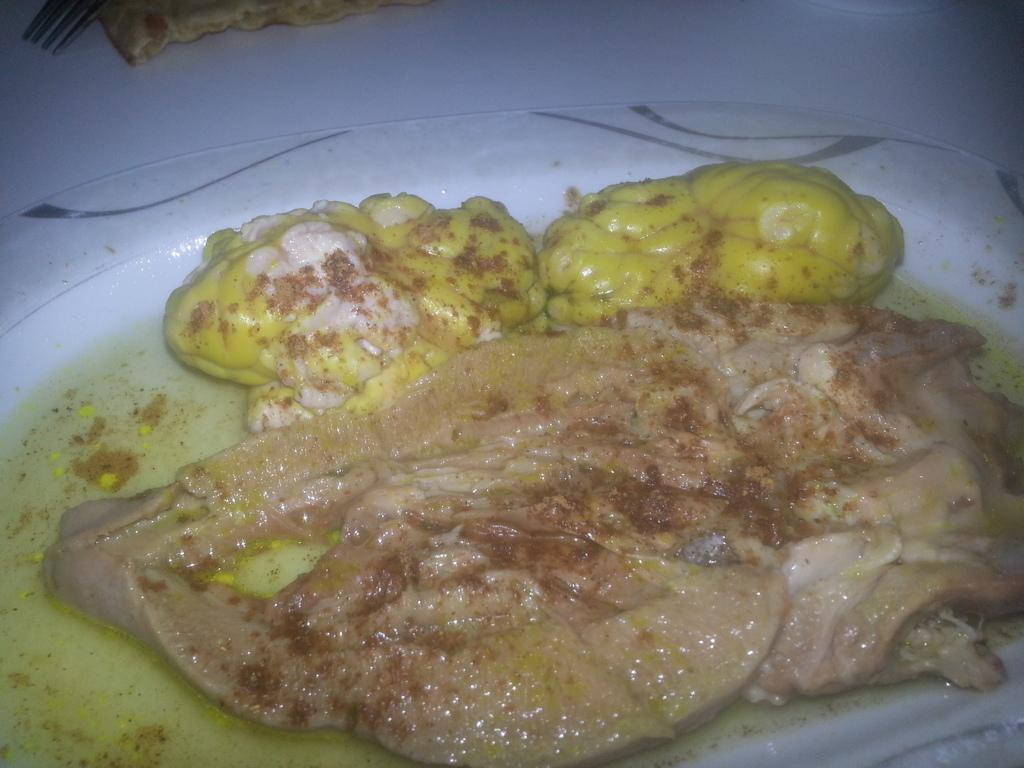What is on the plate that is visible in the image? There is food in a plate in the image. Where is the plate located in the image? The plate is placed on a table. Reasoning: Let' Let's think step by step in order to produce the conversation. We start by identifying the main subject in the image, which is the plate of food. Then, we expand the conversation to include the location of the plate, which is on a table. Each question is designed to elicit a specific detail about the image that is known from the provided facts. Absurd Question/Answer: What type of furniture is visible in the image? There is no furniture visible in the image; only a plate of food and a table are present. Can you tell me what is written in the notebook in the image? There is no notebook present in the image. Is there a window visible in the image? There is no window present in the image; only a plate of food and a table are visible. 